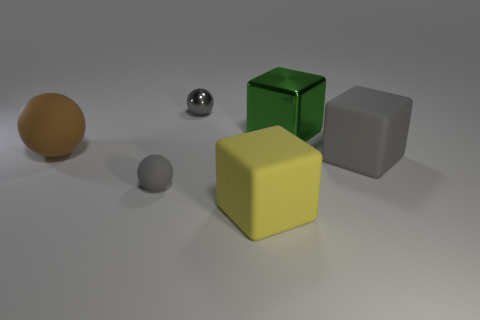Add 3 matte blocks. How many objects exist? 9 Add 5 metal blocks. How many metal blocks are left? 6 Add 1 rubber blocks. How many rubber blocks exist? 3 Subtract 0 brown cylinders. How many objects are left? 6 Subtract all gray matte cubes. Subtract all gray balls. How many objects are left? 3 